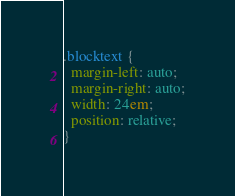Convert code to text. <code><loc_0><loc_0><loc_500><loc_500><_CSS_>.blocktext {
  margin-left: auto;
  margin-right: auto;
  width: 24em;
  position: relative;
}
</code> 